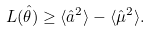<formula> <loc_0><loc_0><loc_500><loc_500>L ( \hat { \theta } ) \geq \langle \hat { a } ^ { 2 } \rangle - \langle \hat { \mu } ^ { 2 } \rangle .</formula> 